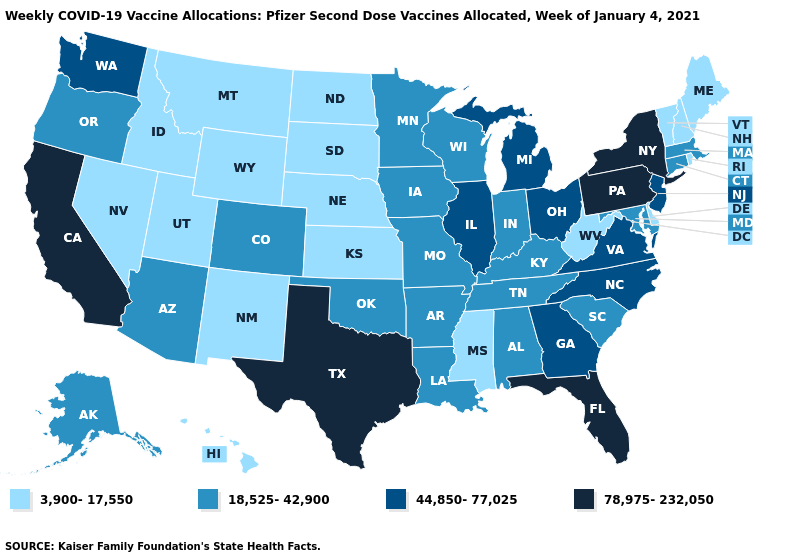Among the states that border Nevada , does California have the lowest value?
Be succinct. No. Among the states that border Arizona , does California have the highest value?
Answer briefly. Yes. Among the states that border Virginia , does North Carolina have the highest value?
Quick response, please. Yes. Does Oklahoma have the lowest value in the USA?
Keep it brief. No. Name the states that have a value in the range 3,900-17,550?
Write a very short answer. Delaware, Hawaii, Idaho, Kansas, Maine, Mississippi, Montana, Nebraska, Nevada, New Hampshire, New Mexico, North Dakota, Rhode Island, South Dakota, Utah, Vermont, West Virginia, Wyoming. What is the value of Maine?
Short answer required. 3,900-17,550. Name the states that have a value in the range 44,850-77,025?
Keep it brief. Georgia, Illinois, Michigan, New Jersey, North Carolina, Ohio, Virginia, Washington. What is the highest value in states that border New Jersey?
Short answer required. 78,975-232,050. What is the value of Vermont?
Write a very short answer. 3,900-17,550. What is the value of Rhode Island?
Keep it brief. 3,900-17,550. Name the states that have a value in the range 3,900-17,550?
Write a very short answer. Delaware, Hawaii, Idaho, Kansas, Maine, Mississippi, Montana, Nebraska, Nevada, New Hampshire, New Mexico, North Dakota, Rhode Island, South Dakota, Utah, Vermont, West Virginia, Wyoming. What is the value of Maryland?
Write a very short answer. 18,525-42,900. Does Texas have the lowest value in the South?
Keep it brief. No. What is the highest value in the USA?
Write a very short answer. 78,975-232,050. How many symbols are there in the legend?
Keep it brief. 4. 